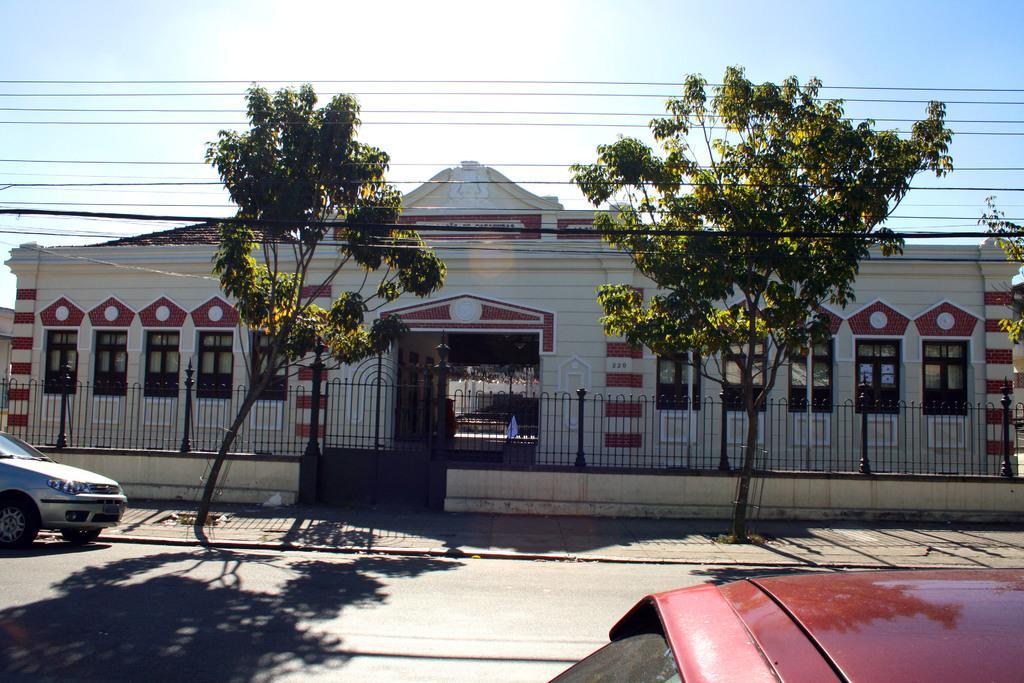In one or two sentences, can you explain what this image depicts? In this image we can see a house, fencing, cars, trees and in the background we can see the sky. 